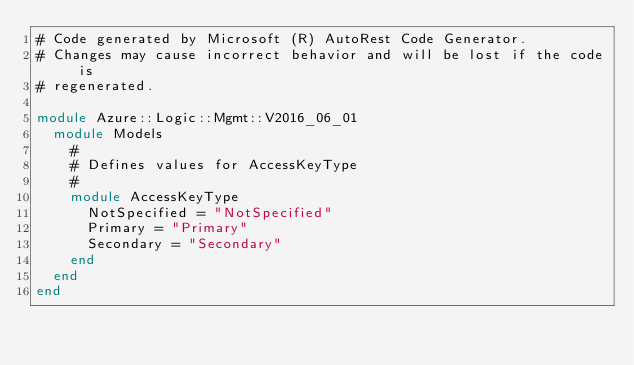<code> <loc_0><loc_0><loc_500><loc_500><_Ruby_># Code generated by Microsoft (R) AutoRest Code Generator.
# Changes may cause incorrect behavior and will be lost if the code is
# regenerated.

module Azure::Logic::Mgmt::V2016_06_01
  module Models
    #
    # Defines values for AccessKeyType
    #
    module AccessKeyType
      NotSpecified = "NotSpecified"
      Primary = "Primary"
      Secondary = "Secondary"
    end
  end
end
</code> 